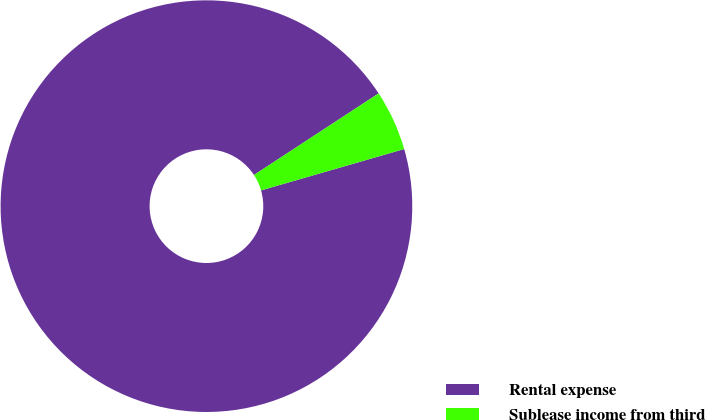<chart> <loc_0><loc_0><loc_500><loc_500><pie_chart><fcel>Rental expense<fcel>Sublease income from third<nl><fcel>95.25%<fcel>4.75%<nl></chart> 